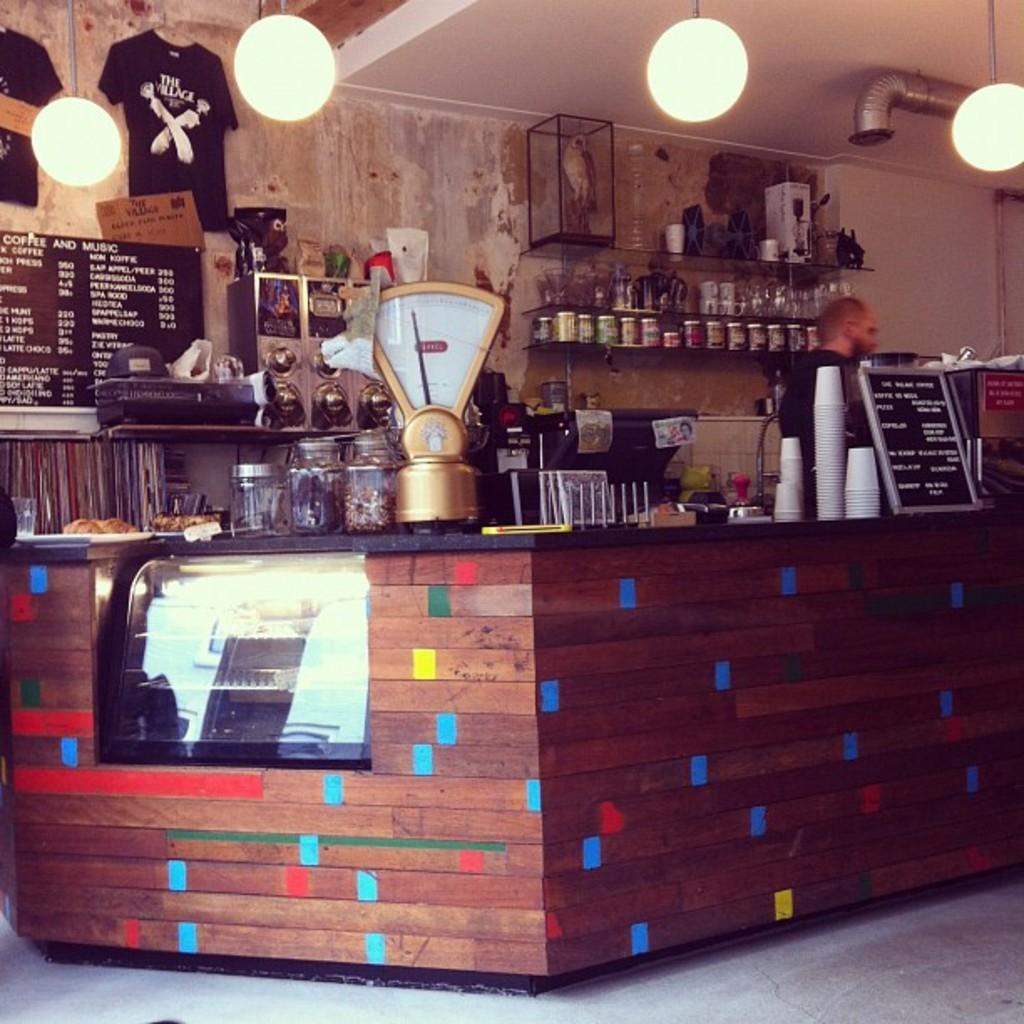Describe this image in one or two sentences. In the center of the image there is a stall on which there are jars,glasses. In the background of the image there is wall on which there is a t-shirt. There is a information board. At the top of the image there is ceiling with lights. To the right side of the image there is a person. At the bottom of the image there is floor. 